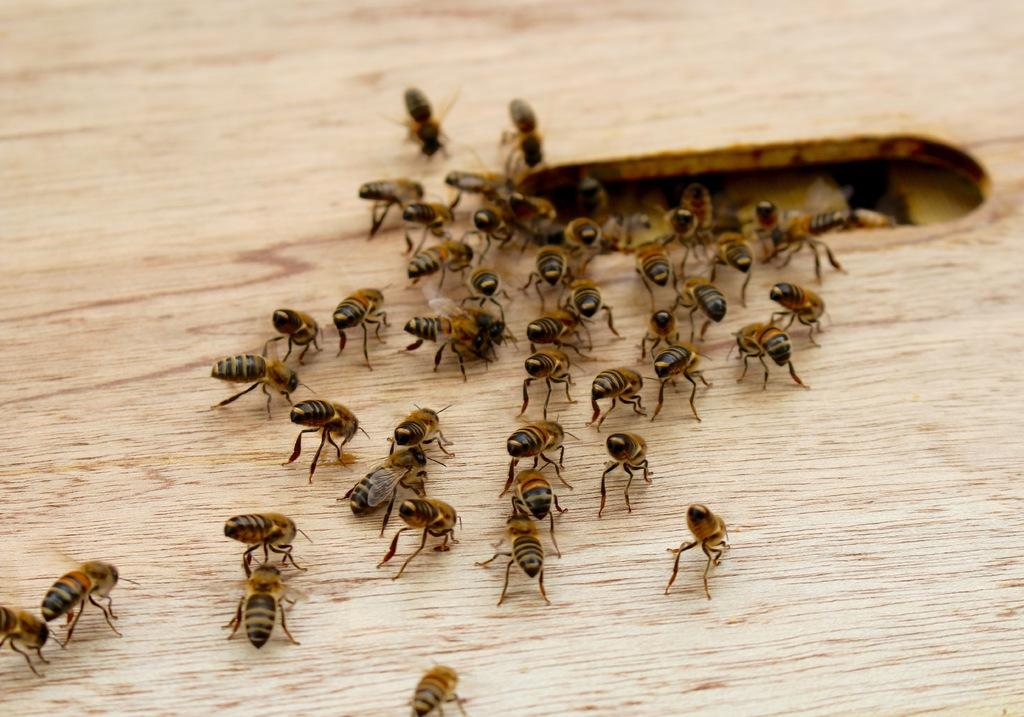What type of creatures can be seen in the image? There are insects in the image. Where are the insects located? The insects are on a wooden surface. What type of animals can be seen at the zoo in the image? There is no zoo present in the image, and no animals other than insects are visible. 